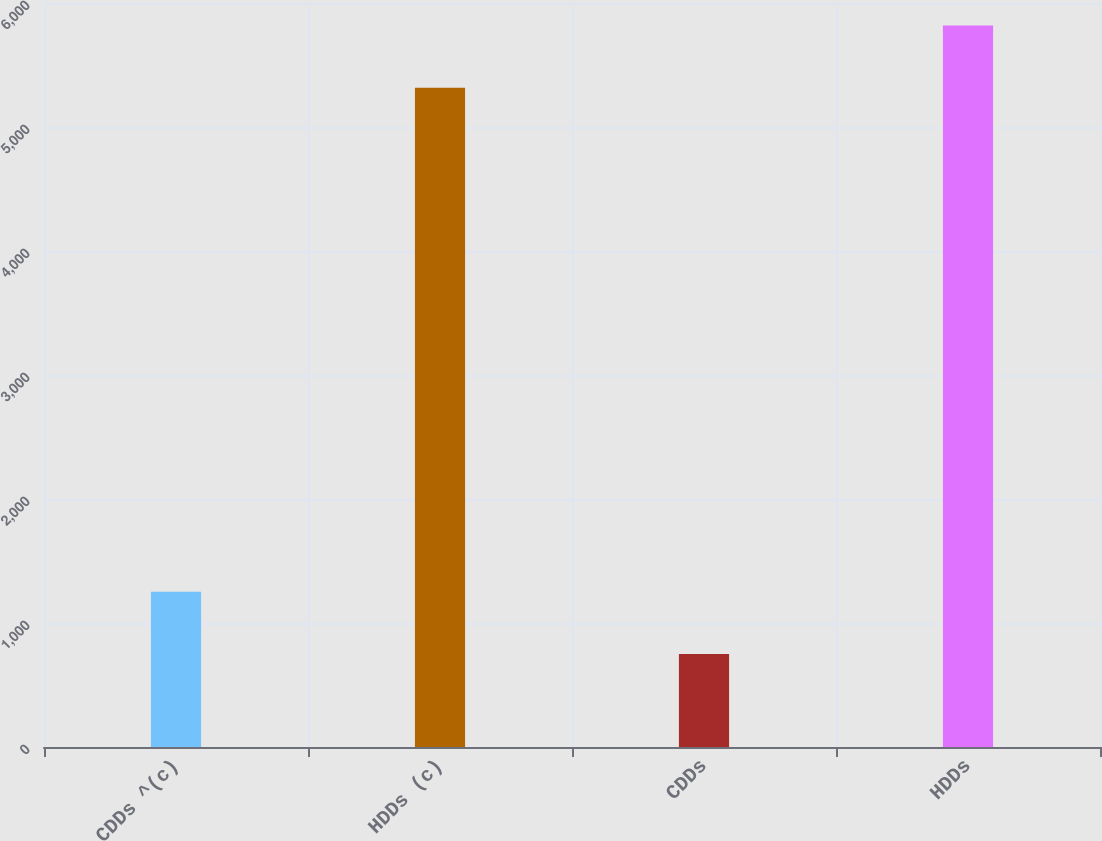Convert chart. <chart><loc_0><loc_0><loc_500><loc_500><bar_chart><fcel>CDDs ^(c)<fcel>HDDs (c)<fcel>CDDs<fcel>HDDs<nl><fcel>1252<fcel>5317<fcel>750<fcel>5819<nl></chart> 